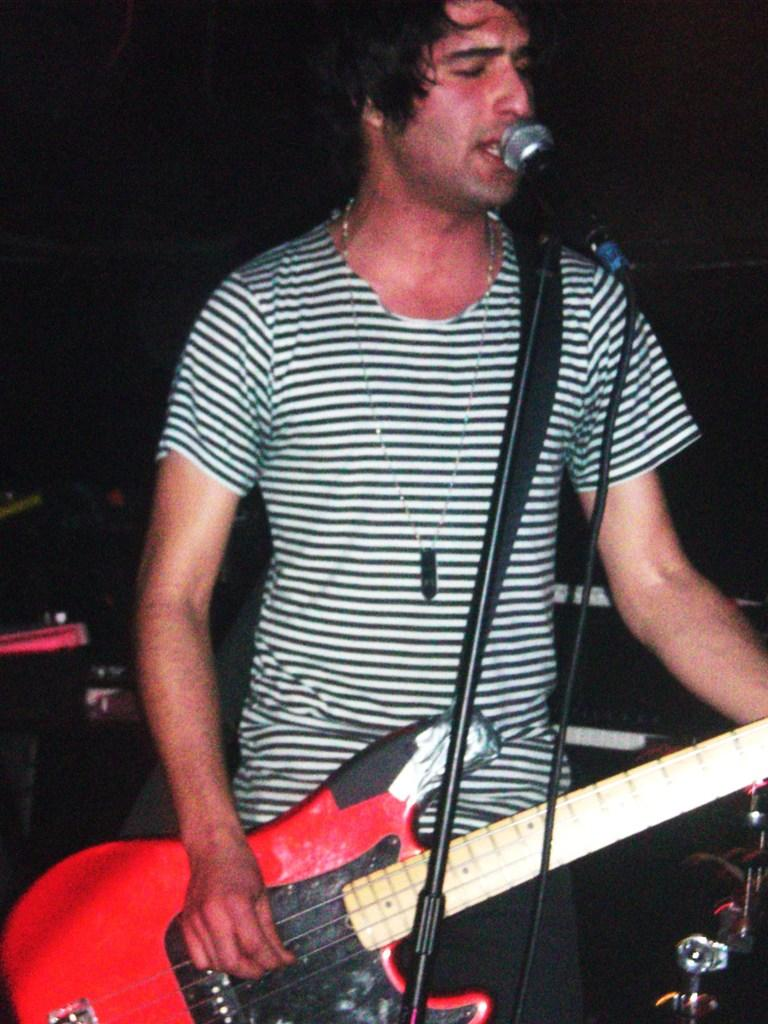What is the man in the image doing? The man is singing and playing a guitar. What object is the man holding while singing? The man is holding a microphone. What can be observed about the background of the image? The background of the image is dark. How many books can be seen on the shelf behind the man in the image? There is no shelf or books visible in the image; it only features the man singing and playing a guitar against a dark background. 